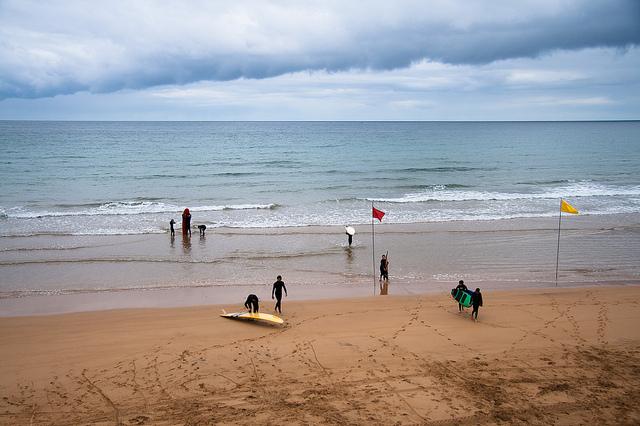How many people have surfboards?
Be succinct. 2. What kind of conditions do the red and yellow flags indicate?
Concise answer only. Stormy. What color is the surfboard?
Write a very short answer. Yellow. Are there more than one wave in the ocean?
Keep it brief. Yes. 